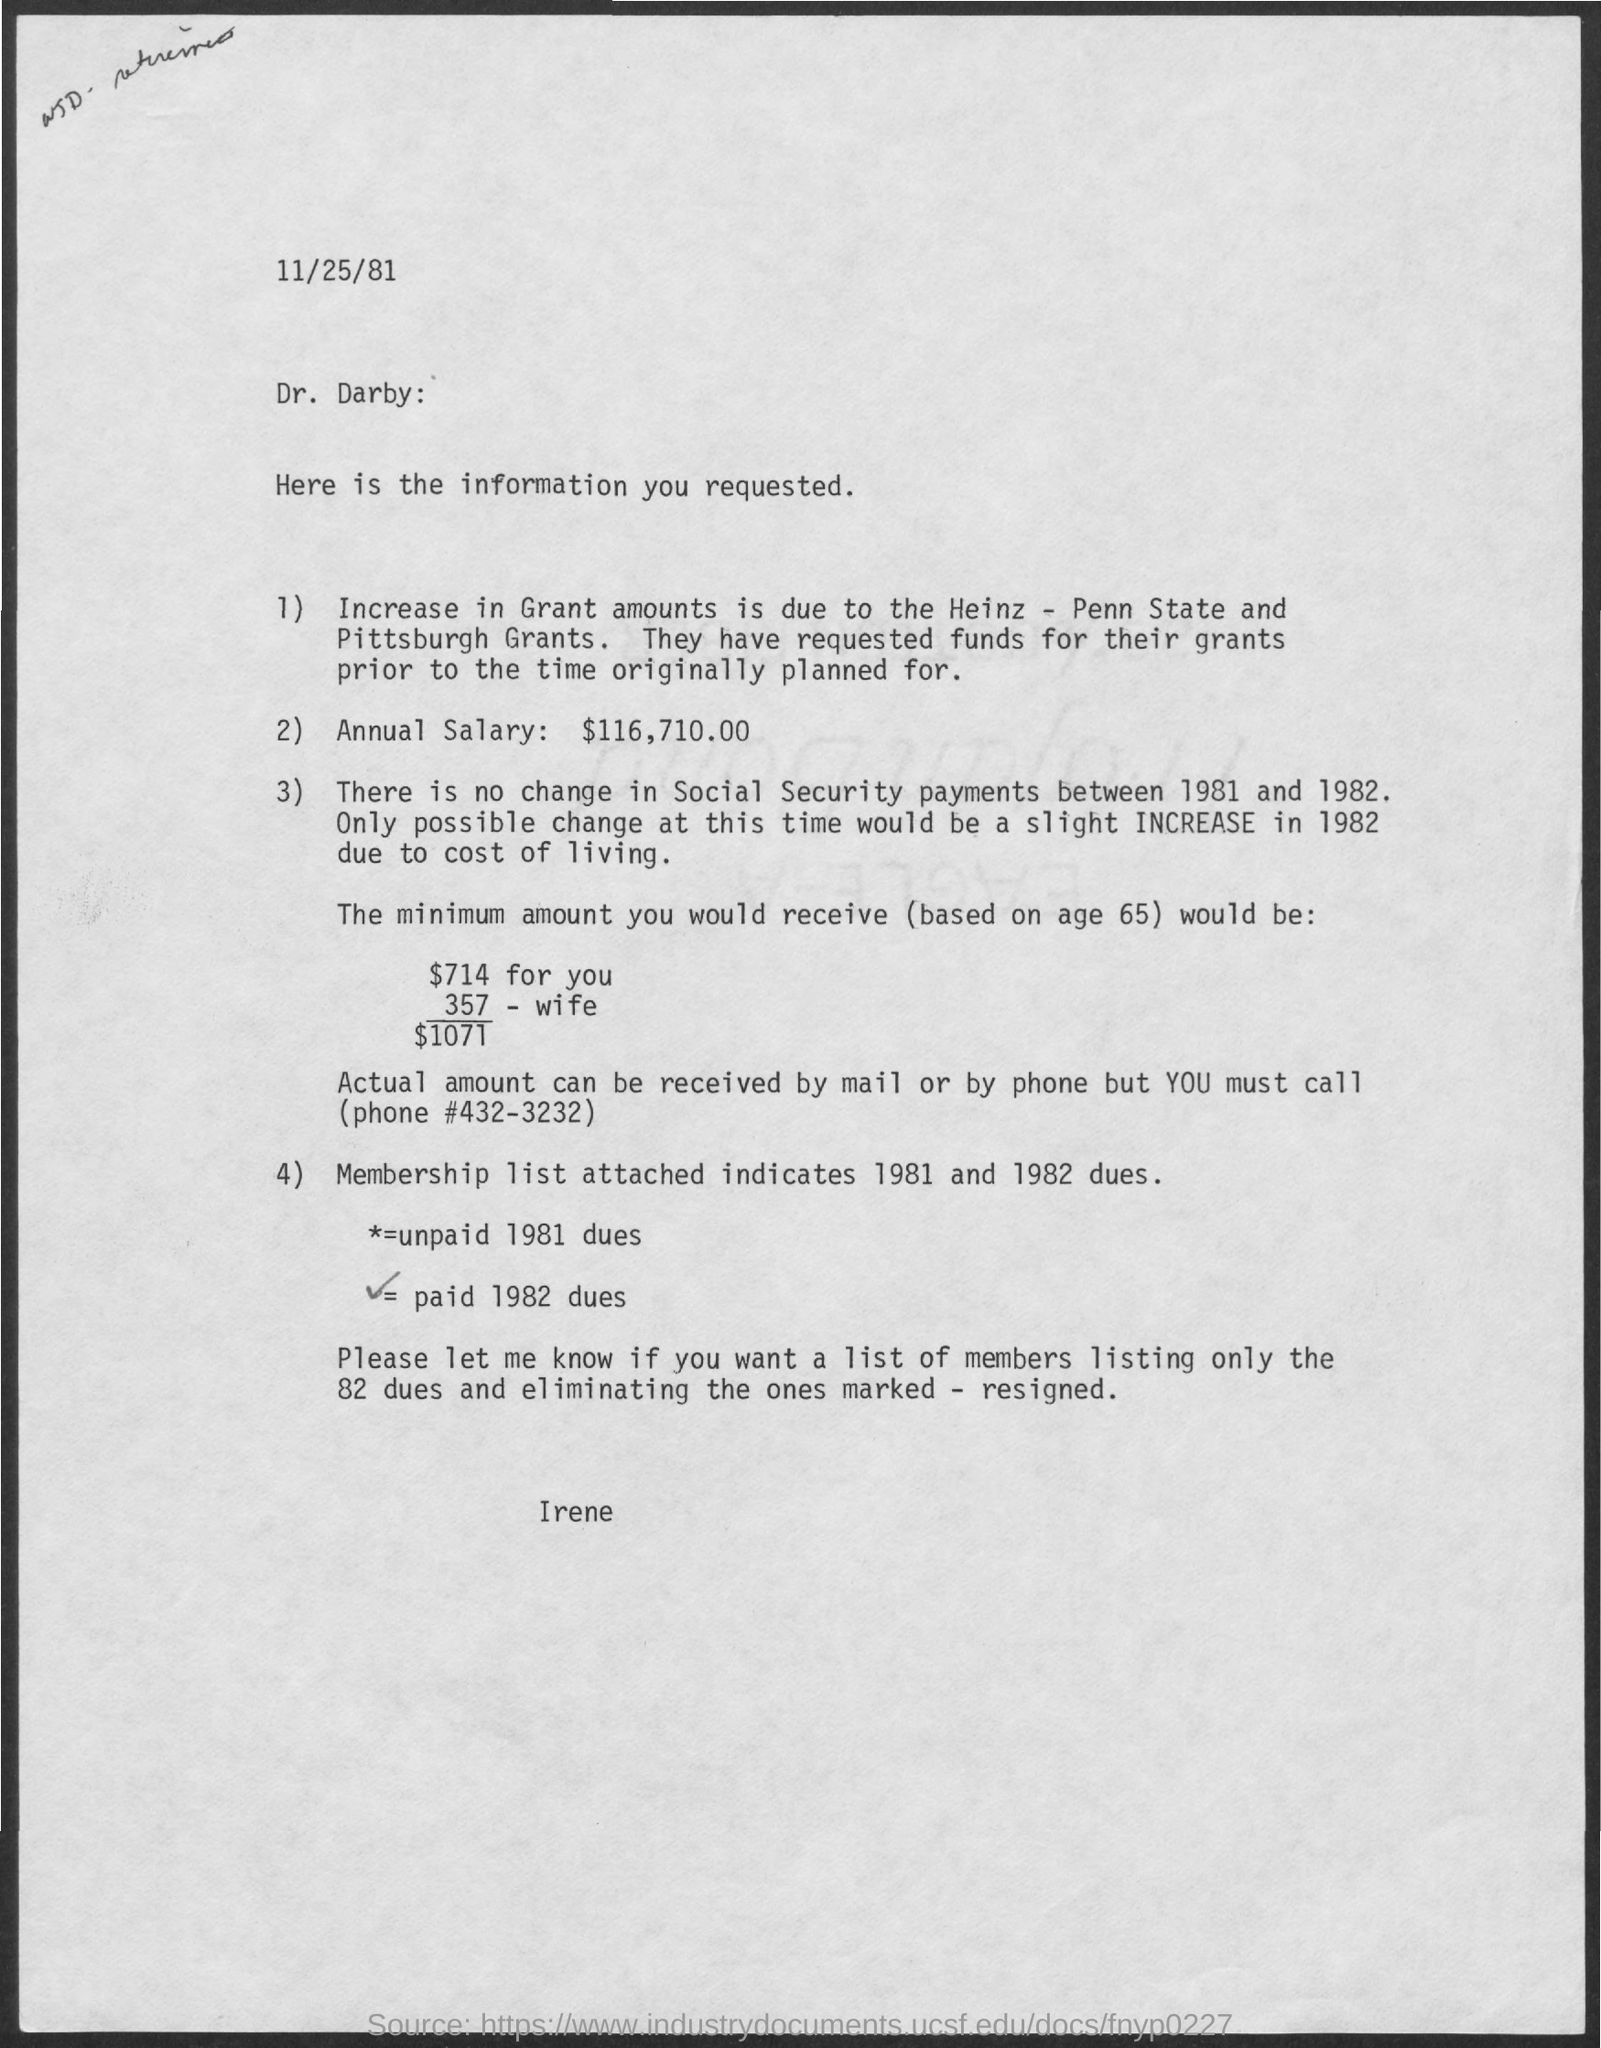What is the annual salary?
Provide a succinct answer. $116,710.00. What is the reason for increase in grant amounts?
Make the answer very short. Heinz - Penn State and Pittsburgh Grants. What is the date at top of the page?
Provide a succinct answer. 11/25/81. To whom the information is related to?
Give a very brief answer. Dr. Darby. 